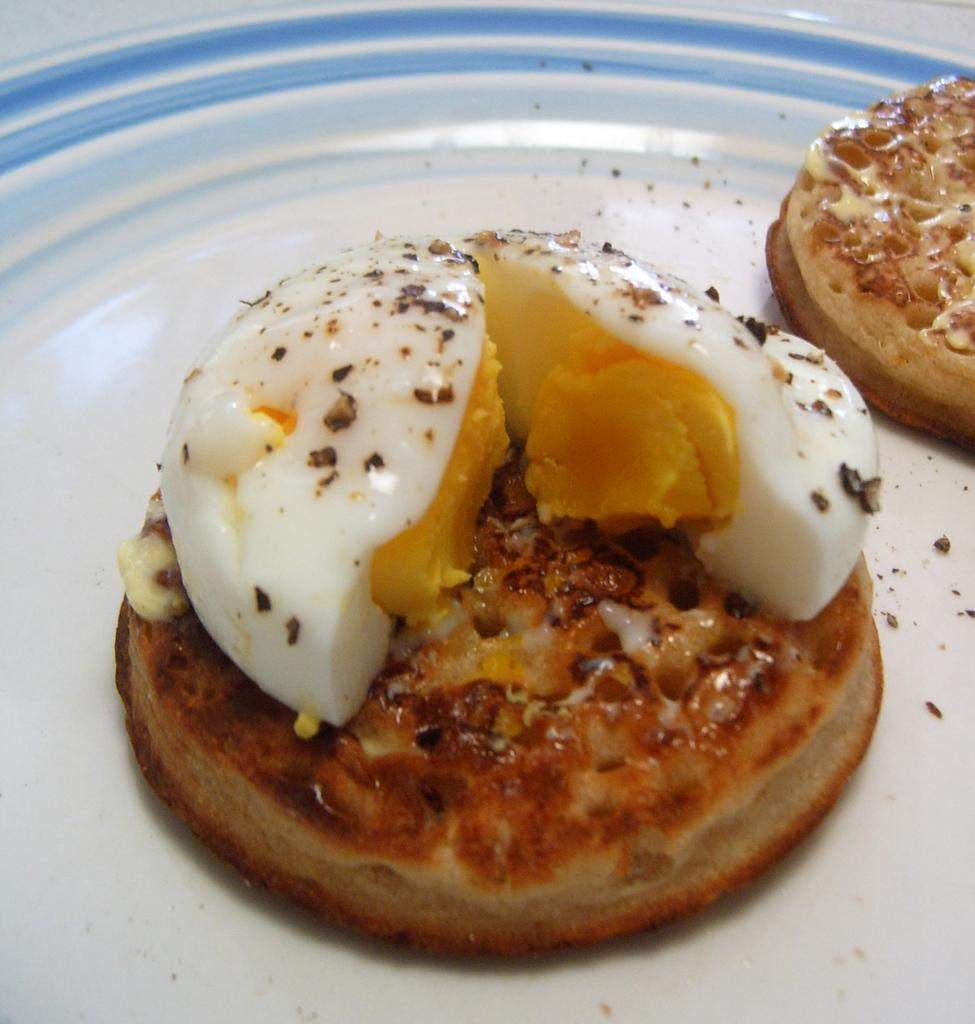What is placed on the plate in the image? There are food items arranged on a plate. What color is the plate? The plate is white in color. What can be seen in the background of the image? The background of the image is white. Can you see a wave crashing on the shore in the image? There is no wave or shore present in the image; it features a plate with food items against a white background. 